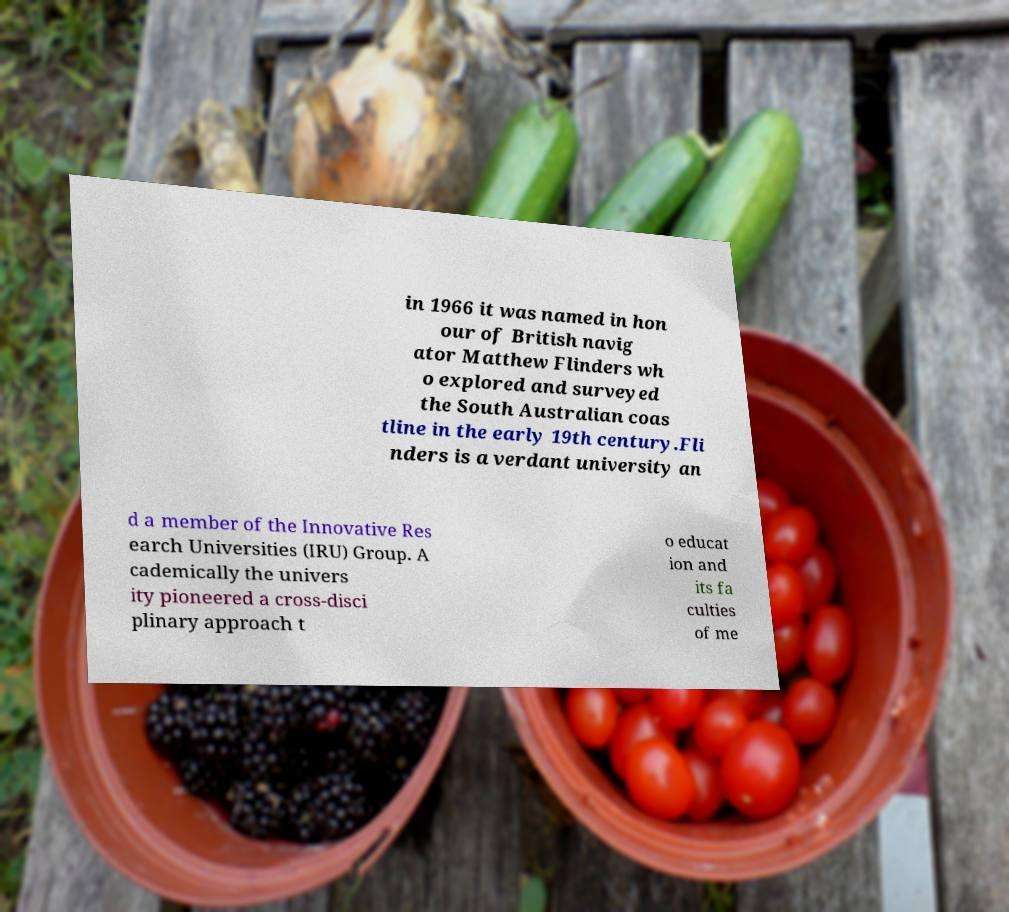Could you assist in decoding the text presented in this image and type it out clearly? in 1966 it was named in hon our of British navig ator Matthew Flinders wh o explored and surveyed the South Australian coas tline in the early 19th century.Fli nders is a verdant university an d a member of the Innovative Res earch Universities (IRU) Group. A cademically the univers ity pioneered a cross-disci plinary approach t o educat ion and its fa culties of me 